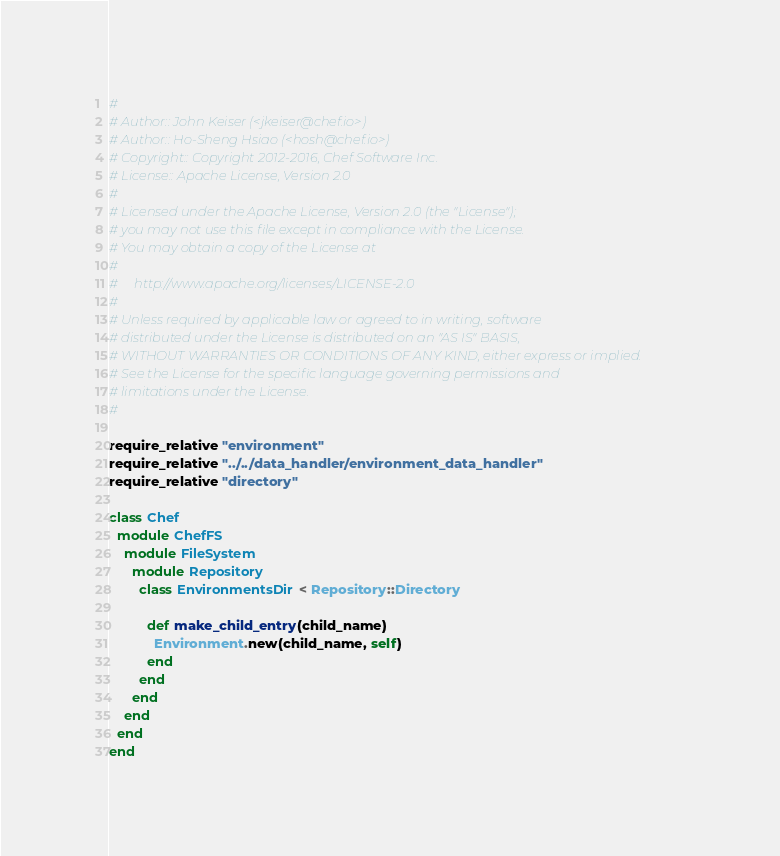Convert code to text. <code><loc_0><loc_0><loc_500><loc_500><_Ruby_>#
# Author:: John Keiser (<jkeiser@chef.io>)
# Author:: Ho-Sheng Hsiao (<hosh@chef.io>)
# Copyright:: Copyright 2012-2016, Chef Software Inc.
# License:: Apache License, Version 2.0
#
# Licensed under the Apache License, Version 2.0 (the "License");
# you may not use this file except in compliance with the License.
# You may obtain a copy of the License at
#
#     http://www.apache.org/licenses/LICENSE-2.0
#
# Unless required by applicable law or agreed to in writing, software
# distributed under the License is distributed on an "AS IS" BASIS,
# WITHOUT WARRANTIES OR CONDITIONS OF ANY KIND, either express or implied.
# See the License for the specific language governing permissions and
# limitations under the License.
#

require_relative "environment"
require_relative "../../data_handler/environment_data_handler"
require_relative "directory"

class Chef
  module ChefFS
    module FileSystem
      module Repository
        class EnvironmentsDir < Repository::Directory

          def make_child_entry(child_name)
            Environment.new(child_name, self)
          end
        end
      end
    end
  end
end
</code> 